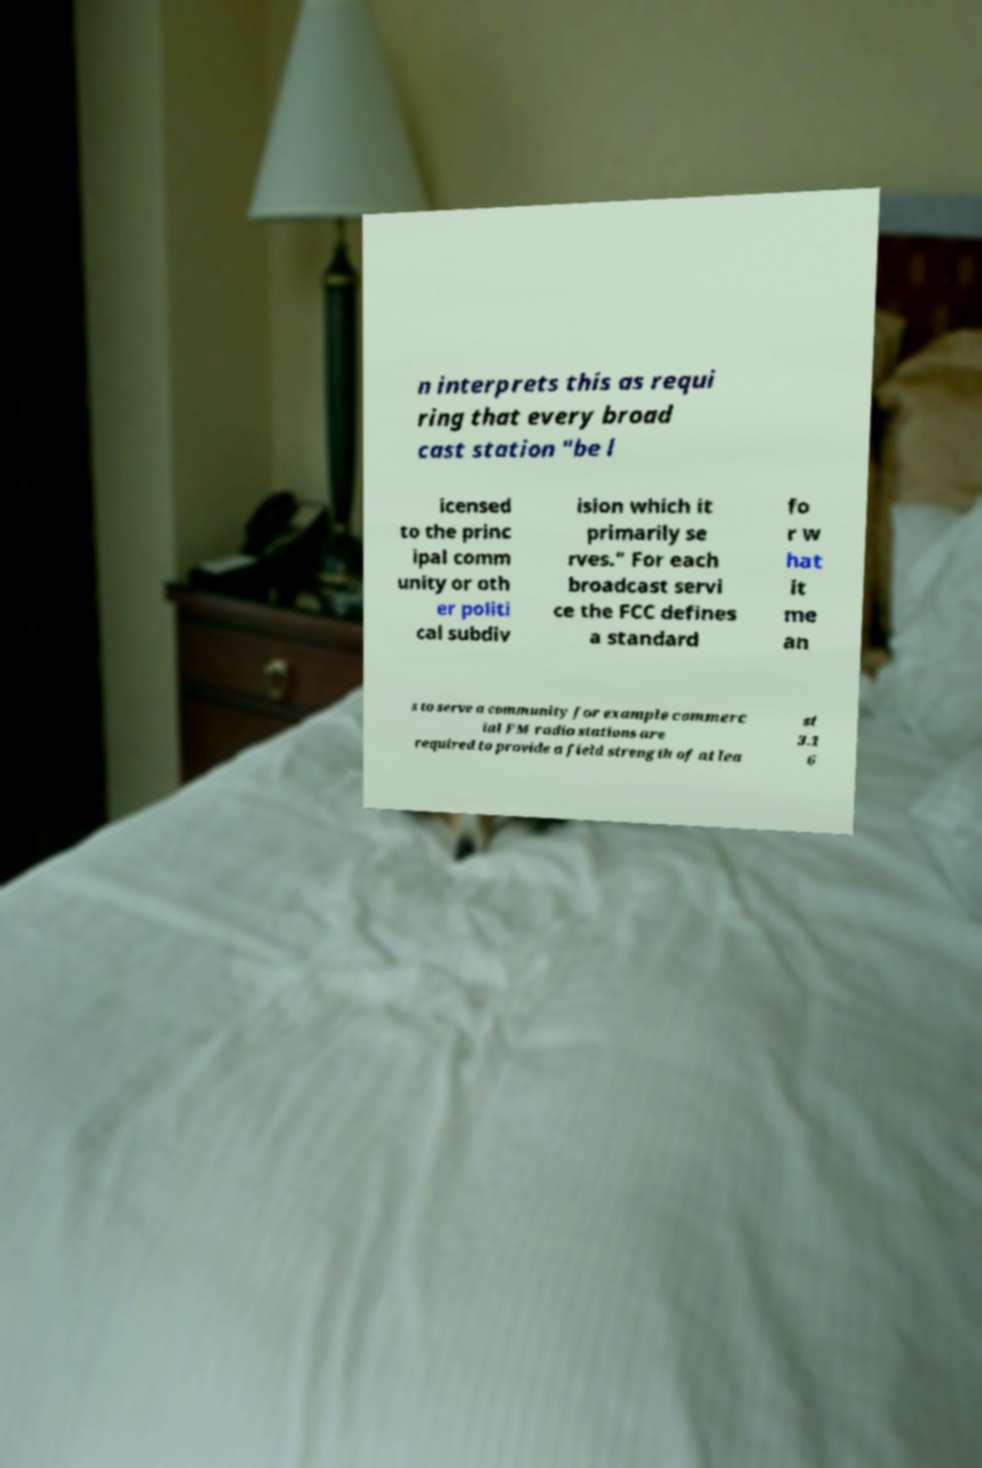For documentation purposes, I need the text within this image transcribed. Could you provide that? n interprets this as requi ring that every broad cast station "be l icensed to the princ ipal comm unity or oth er politi cal subdiv ision which it primarily se rves." For each broadcast servi ce the FCC defines a standard fo r w hat it me an s to serve a community for example commerc ial FM radio stations are required to provide a field strength of at lea st 3.1 6 